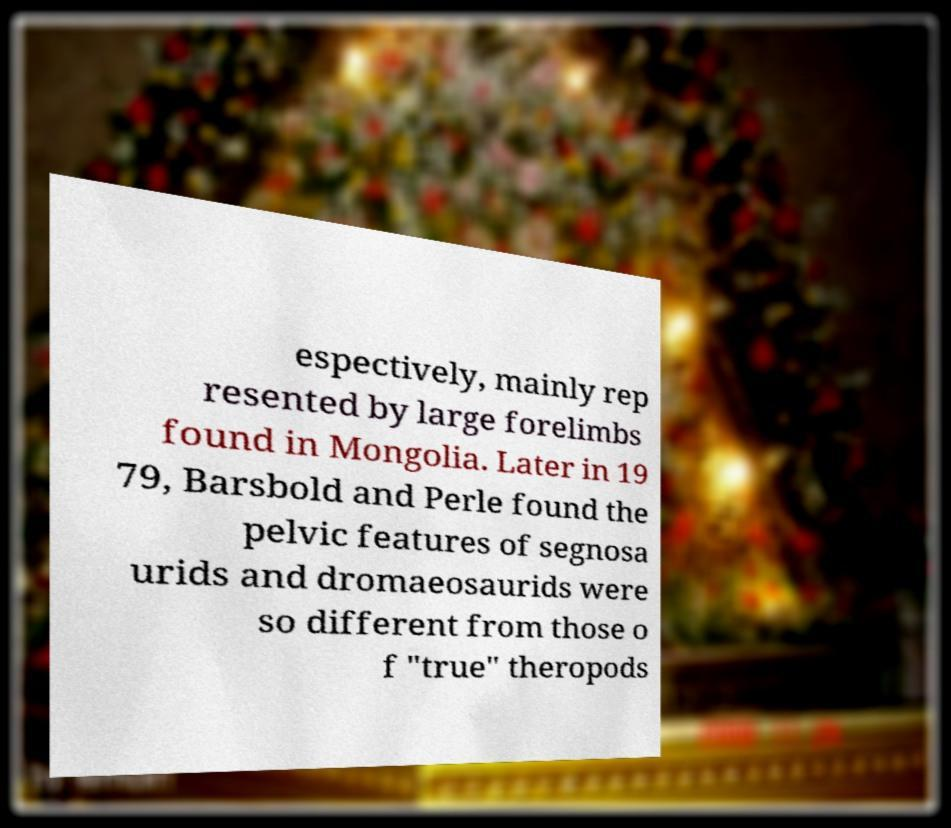What messages or text are displayed in this image? I need them in a readable, typed format. espectively, mainly rep resented by large forelimbs found in Mongolia. Later in 19 79, Barsbold and Perle found the pelvic features of segnosa urids and dromaeosaurids were so different from those o f "true" theropods 